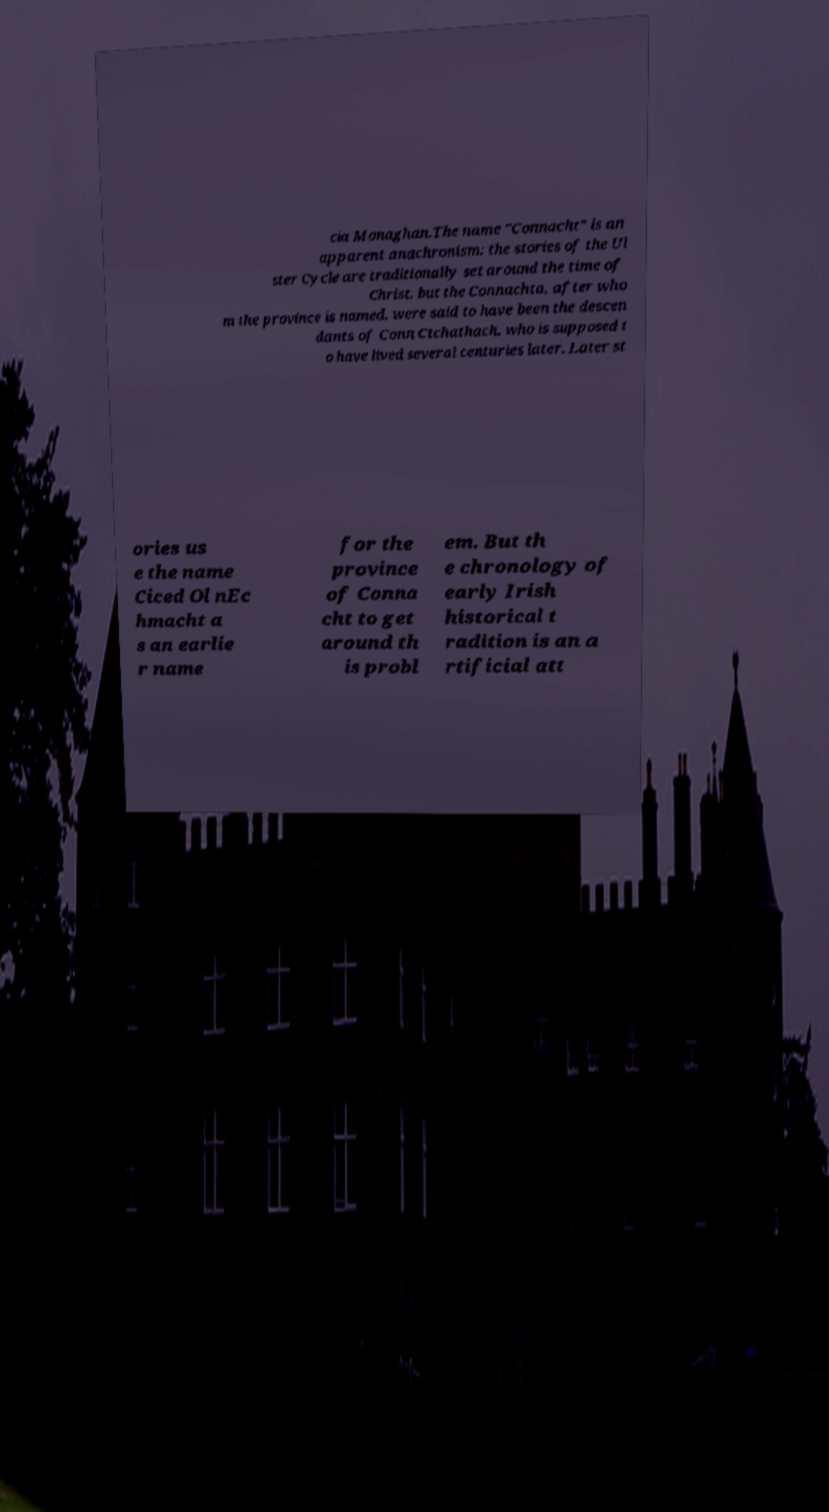Could you assist in decoding the text presented in this image and type it out clearly? cia Monaghan.The name "Connacht" is an apparent anachronism: the stories of the Ul ster Cycle are traditionally set around the time of Christ, but the Connachta, after who m the province is named, were said to have been the descen dants of Conn Ctchathach, who is supposed t o have lived several centuries later. Later st ories us e the name Ciced Ol nEc hmacht a s an earlie r name for the province of Conna cht to get around th is probl em. But th e chronology of early Irish historical t radition is an a rtificial att 